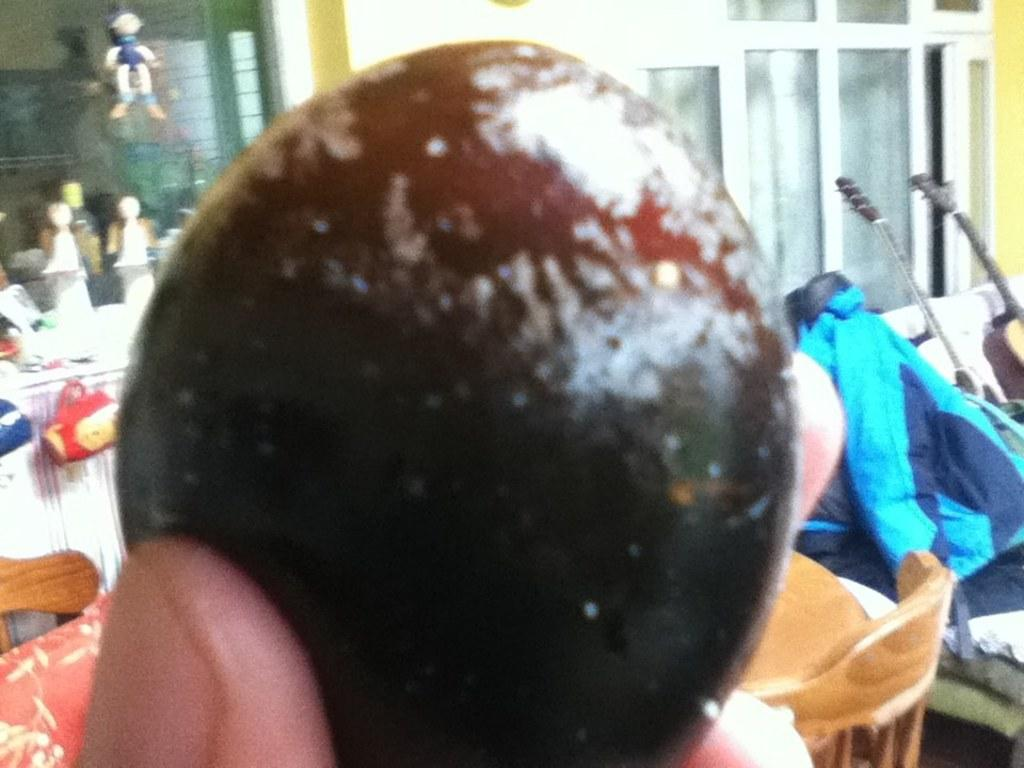What is the person holding in the image? There is a person holding an object in the image. What can be seen in the background of the image? In the background of the image, there are cars, toys, a cup, cloth, a guitar, windows, and a wall, as well as other unspecified objects. What type of breakfast is being prepared in the image? There is no indication of breakfast or any food preparation in the image. 